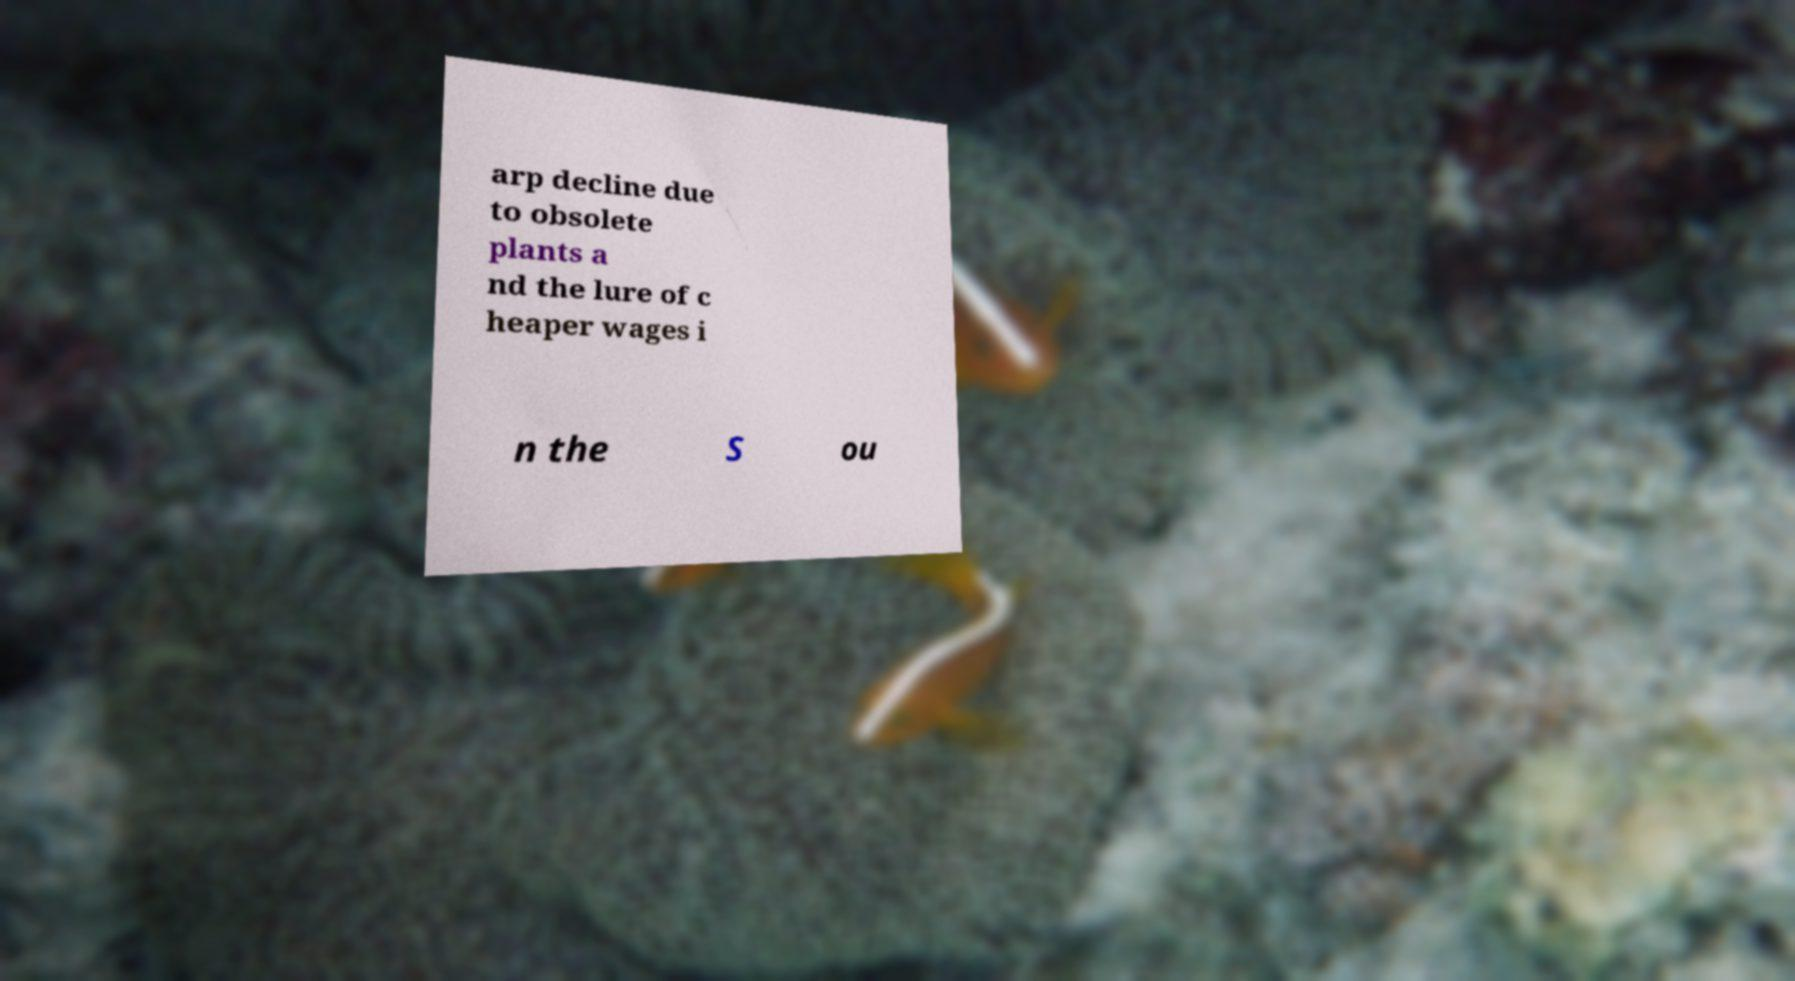Please identify and transcribe the text found in this image. arp decline due to obsolete plants a nd the lure of c heaper wages i n the S ou 